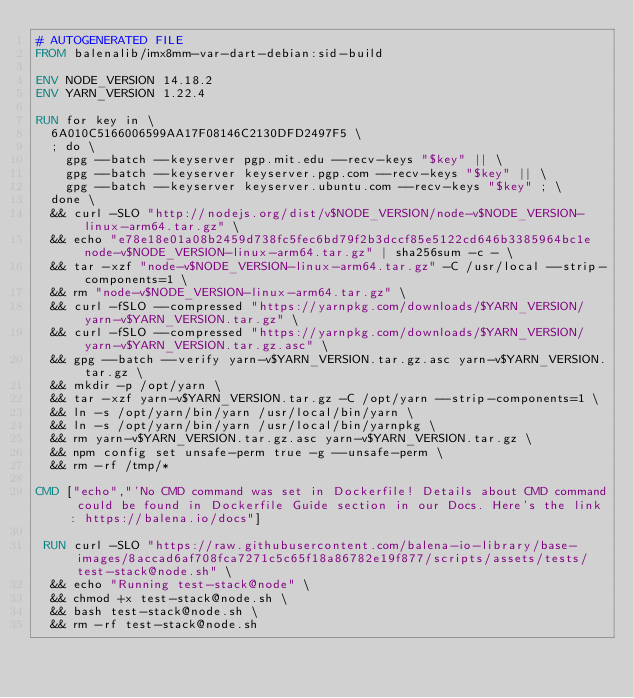Convert code to text. <code><loc_0><loc_0><loc_500><loc_500><_Dockerfile_># AUTOGENERATED FILE
FROM balenalib/imx8mm-var-dart-debian:sid-build

ENV NODE_VERSION 14.18.2
ENV YARN_VERSION 1.22.4

RUN for key in \
	6A010C5166006599AA17F08146C2130DFD2497F5 \
	; do \
		gpg --batch --keyserver pgp.mit.edu --recv-keys "$key" || \
		gpg --batch --keyserver keyserver.pgp.com --recv-keys "$key" || \
		gpg --batch --keyserver keyserver.ubuntu.com --recv-keys "$key" ; \
	done \
	&& curl -SLO "http://nodejs.org/dist/v$NODE_VERSION/node-v$NODE_VERSION-linux-arm64.tar.gz" \
	&& echo "e78e18e01a08b2459d738fc5fec6bd79f2b3dccf85e5122cd646b3385964bc1e  node-v$NODE_VERSION-linux-arm64.tar.gz" | sha256sum -c - \
	&& tar -xzf "node-v$NODE_VERSION-linux-arm64.tar.gz" -C /usr/local --strip-components=1 \
	&& rm "node-v$NODE_VERSION-linux-arm64.tar.gz" \
	&& curl -fSLO --compressed "https://yarnpkg.com/downloads/$YARN_VERSION/yarn-v$YARN_VERSION.tar.gz" \
	&& curl -fSLO --compressed "https://yarnpkg.com/downloads/$YARN_VERSION/yarn-v$YARN_VERSION.tar.gz.asc" \
	&& gpg --batch --verify yarn-v$YARN_VERSION.tar.gz.asc yarn-v$YARN_VERSION.tar.gz \
	&& mkdir -p /opt/yarn \
	&& tar -xzf yarn-v$YARN_VERSION.tar.gz -C /opt/yarn --strip-components=1 \
	&& ln -s /opt/yarn/bin/yarn /usr/local/bin/yarn \
	&& ln -s /opt/yarn/bin/yarn /usr/local/bin/yarnpkg \
	&& rm yarn-v$YARN_VERSION.tar.gz.asc yarn-v$YARN_VERSION.tar.gz \
	&& npm config set unsafe-perm true -g --unsafe-perm \
	&& rm -rf /tmp/*

CMD ["echo","'No CMD command was set in Dockerfile! Details about CMD command could be found in Dockerfile Guide section in our Docs. Here's the link: https://balena.io/docs"]

 RUN curl -SLO "https://raw.githubusercontent.com/balena-io-library/base-images/8accad6af708fca7271c5c65f18a86782e19f877/scripts/assets/tests/test-stack@node.sh" \
  && echo "Running test-stack@node" \
  && chmod +x test-stack@node.sh \
  && bash test-stack@node.sh \
  && rm -rf test-stack@node.sh 
</code> 